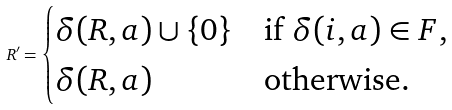<formula> <loc_0><loc_0><loc_500><loc_500>R ^ { \prime } = \begin{cases} \delta ( R , a ) \cup \{ 0 \} & \text {if $\delta(i,a) \in F$,} \\ \delta ( R , a ) & \text {otherwise.} \end{cases}</formula> 